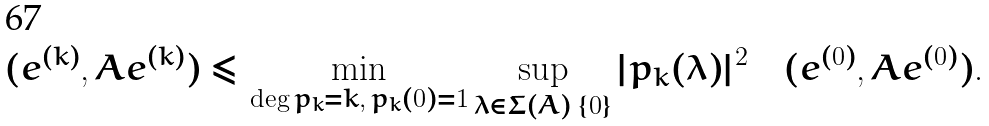<formula> <loc_0><loc_0><loc_500><loc_500>( e ^ { ( k ) } , A e ^ { ( k ) } ) \leq \min _ { \deg p _ { k } = k , \, p _ { k } ( 0 ) = 1 } \sup _ { \lambda \in \Sigma ( A ) \ \{ 0 \} } | p _ { k } ( \lambda ) | ^ { 2 } \quad ( e ^ { ( 0 ) } , A e ^ { ( 0 ) } ) .</formula> 